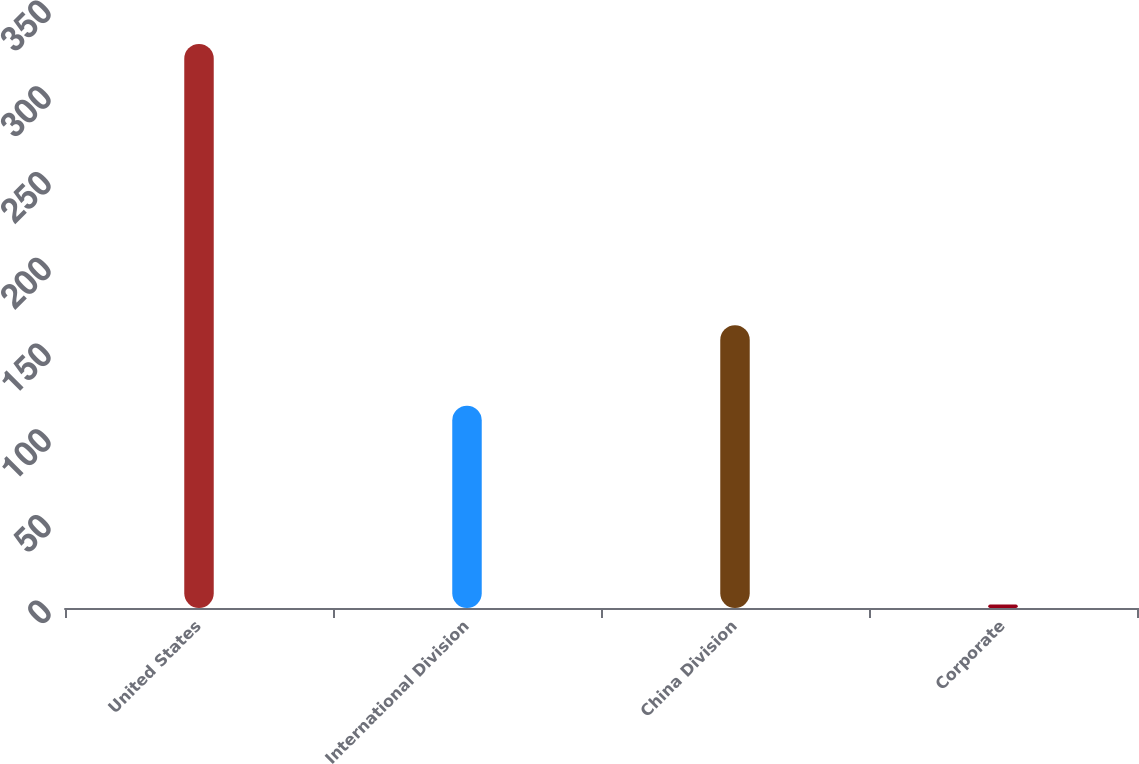Convert chart. <chart><loc_0><loc_0><loc_500><loc_500><bar_chart><fcel>United States<fcel>International Division<fcel>China Division<fcel>Corporate<nl><fcel>329<fcel>118<fcel>165<fcel>2<nl></chart> 